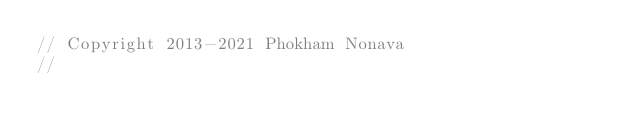Convert code to text. <code><loc_0><loc_0><loc_500><loc_500><_C++_>// Copyright 2013-2021 Phokham Nonava
//</code> 